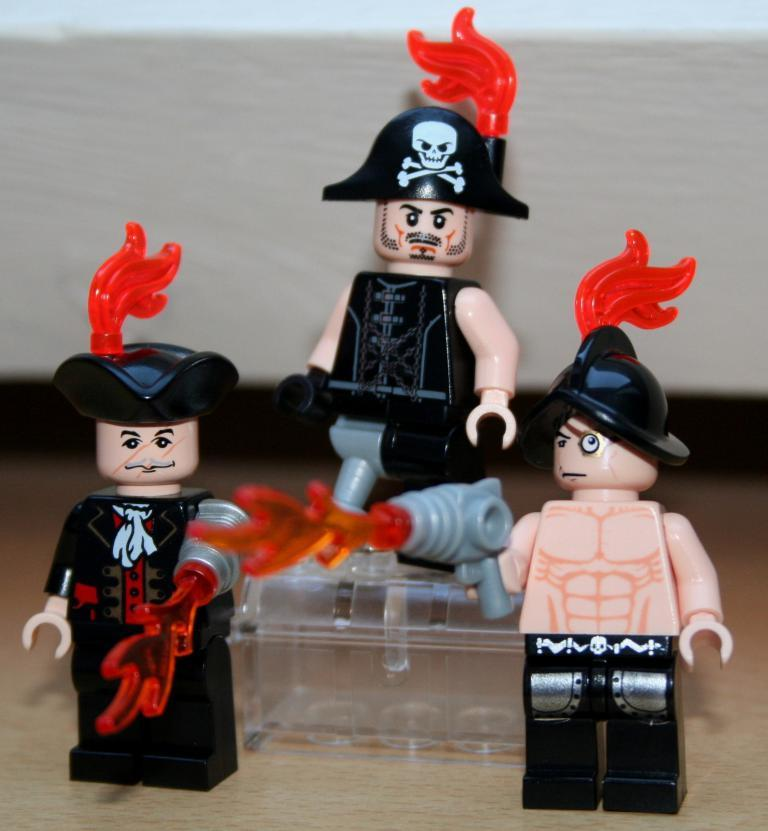What type of toys are in the image? There are Lego city toys in the image. How many toys are standing on the floor? Two toys are standing on the floor. Where is the third toy located? Another toy is standing on a platform. Can you describe the platform in the image? There is a platform visible in the background. What is the chance of the toys paying off their debt in the image? There is no mention of debt in the image, as it features Lego city toys, which are inanimate objects and cannot have debt. 